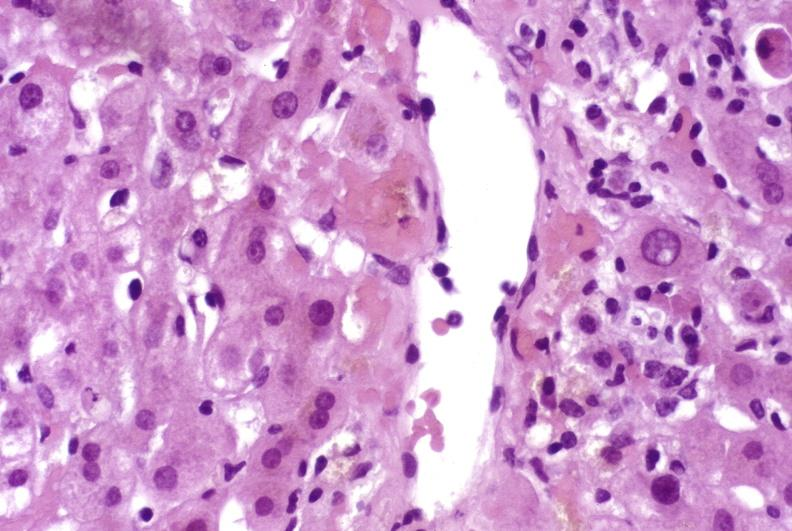s fallopian tube present?
Answer the question using a single word or phrase. No 